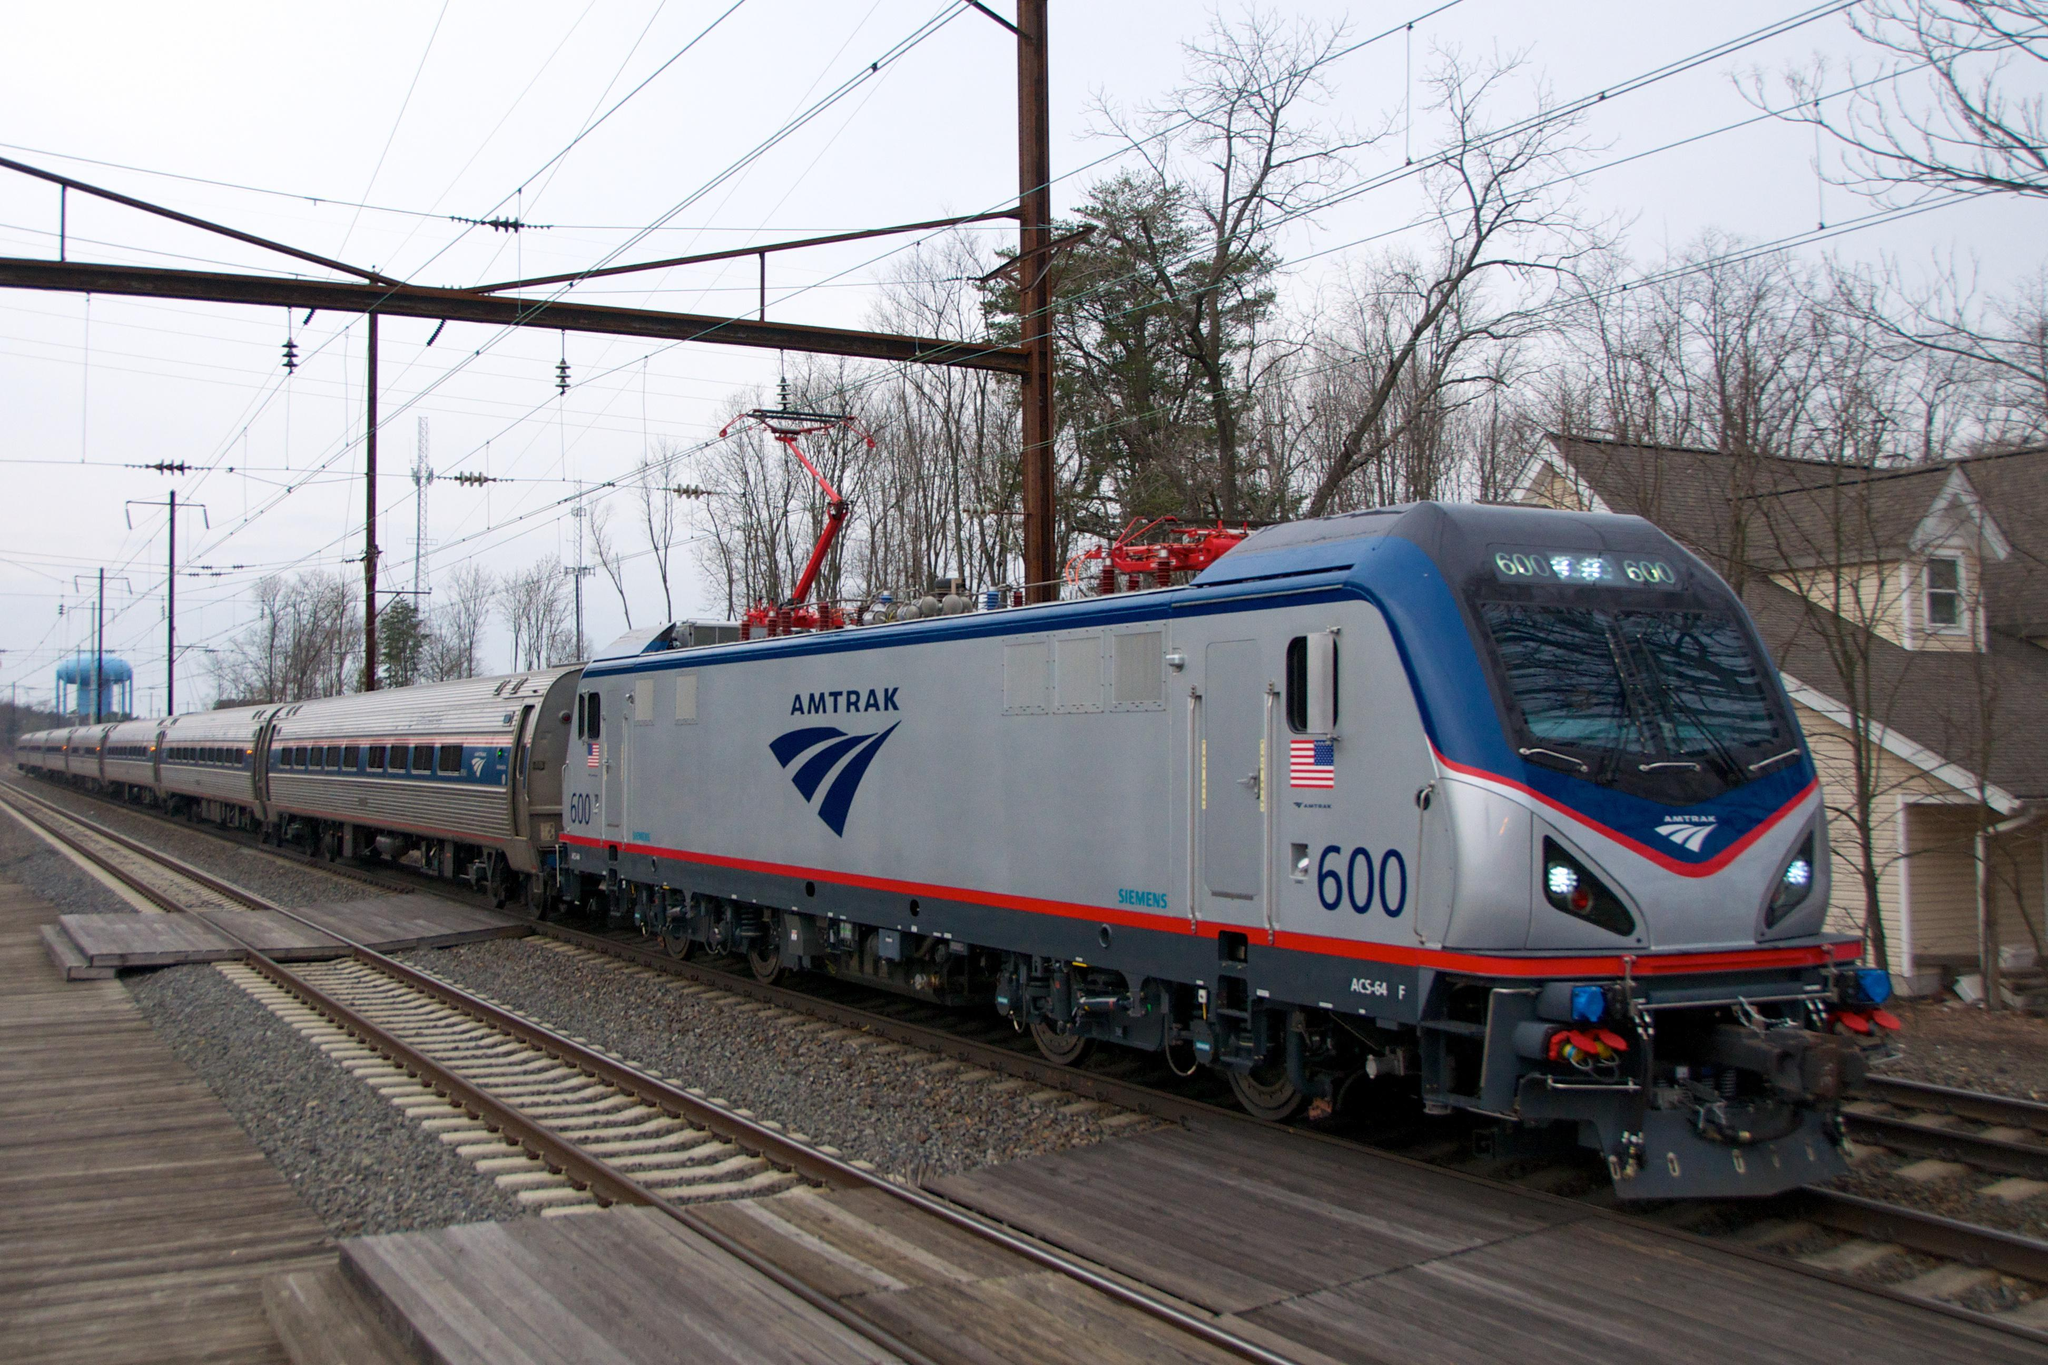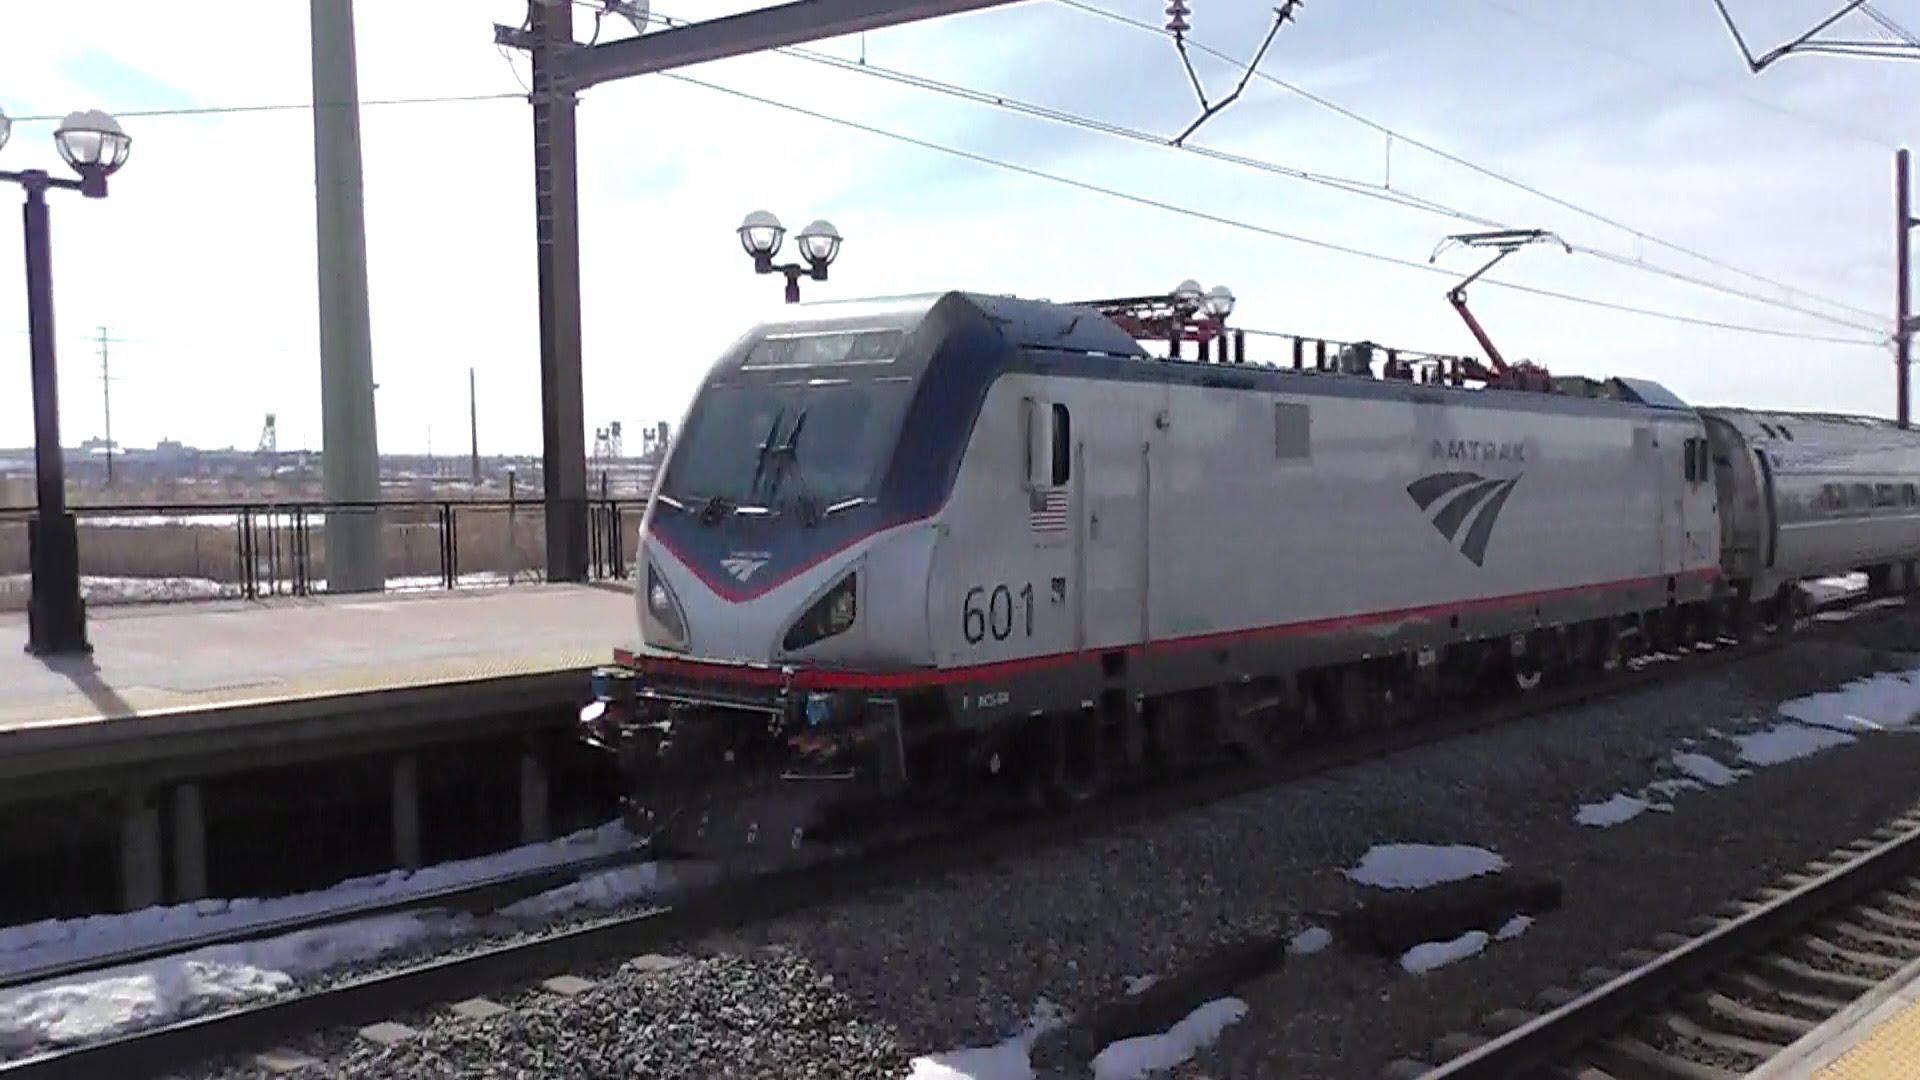The first image is the image on the left, the second image is the image on the right. Evaluate the accuracy of this statement regarding the images: "There are at least six power poles in the image on the right.". Is it true? Answer yes or no. No. 